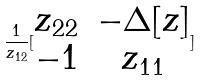<formula> <loc_0><loc_0><loc_500><loc_500>\frac { 1 } { z _ { 1 2 } } [ \begin{matrix} z _ { 2 2 } & - \Delta [ z ] \\ - 1 & z _ { 1 1 } \end{matrix} ]</formula> 